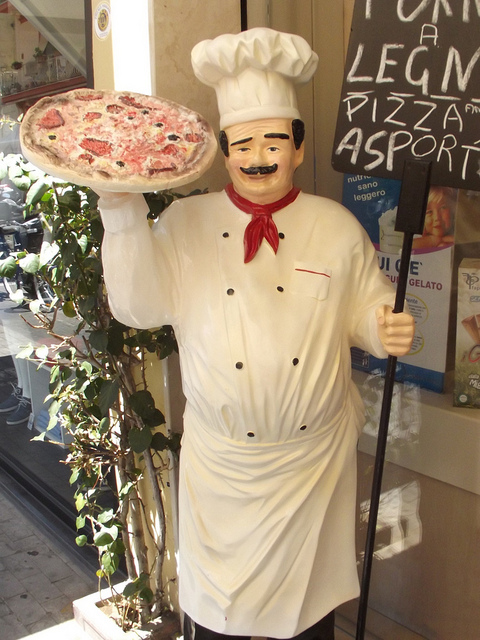What is the statue holding? The statue is depicted as a chef holding a pizza, which is characteristic of an Italian restaurant setting, often used to symbolize the type of cuisine offered. This playful representation captures the essence of Italian culinary tradition. 